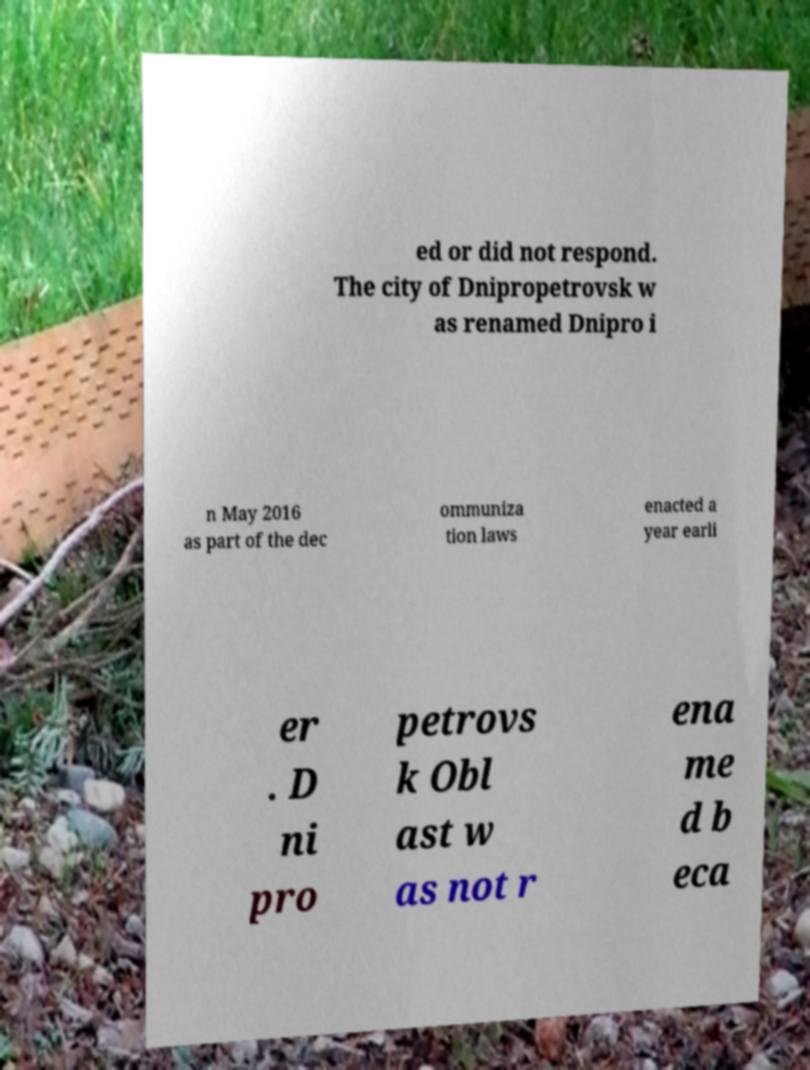There's text embedded in this image that I need extracted. Can you transcribe it verbatim? ed or did not respond. The city of Dnipropetrovsk w as renamed Dnipro i n May 2016 as part of the dec ommuniza tion laws enacted a year earli er . D ni pro petrovs k Obl ast w as not r ena me d b eca 